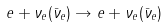<formula> <loc_0><loc_0><loc_500><loc_500>e + \nu _ { e } ( \bar { \nu } _ { e } ) \rightarrow e + \nu _ { e } ( \bar { \nu } _ { e } )</formula> 